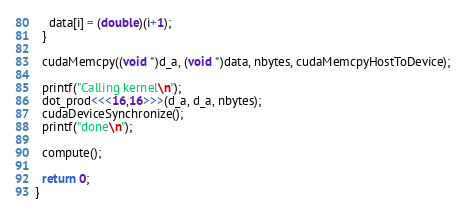Convert code to text. <code><loc_0><loc_0><loc_500><loc_500><_Cuda_>    data[i] = (double)(i+1);
  }

  cudaMemcpy((void *)d_a, (void *)data, nbytes, cudaMemcpyHostToDevice);

  printf("Calling kernel\n");
  dot_prod<<<16,16>>>(d_a, d_a, nbytes);
  cudaDeviceSynchronize();
  printf("done\n");

  compute();

  return 0;
}
</code> 